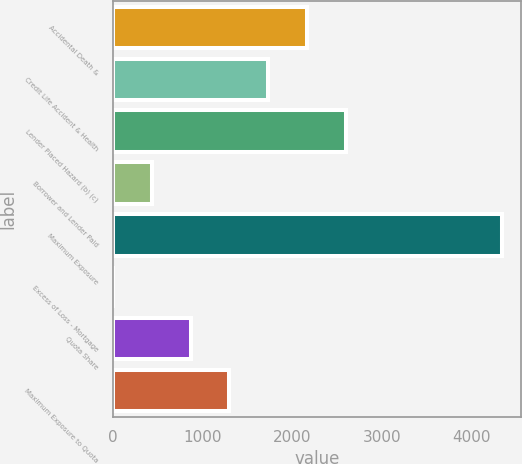Convert chart. <chart><loc_0><loc_0><loc_500><loc_500><bar_chart><fcel>Accidental Death &<fcel>Credit Life Accident & Health<fcel>Lender Placed Hazard (b) (c)<fcel>Borrower and Lender Paid<fcel>Maximum Exposure<fcel>Excess of Loss - Mortgage<fcel>Quota Share<fcel>Maximum Exposure to Quota<nl><fcel>2171.5<fcel>1737.4<fcel>2605.6<fcel>435.1<fcel>4342<fcel>1<fcel>869.2<fcel>1303.3<nl></chart> 